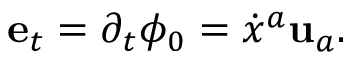<formula> <loc_0><loc_0><loc_500><loc_500>{ e } _ { t } = \partial _ { t } \phi _ { 0 } = \dot { x } ^ { a } { u } _ { a } .</formula> 